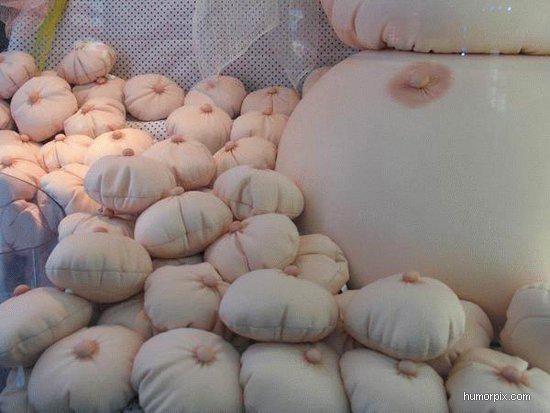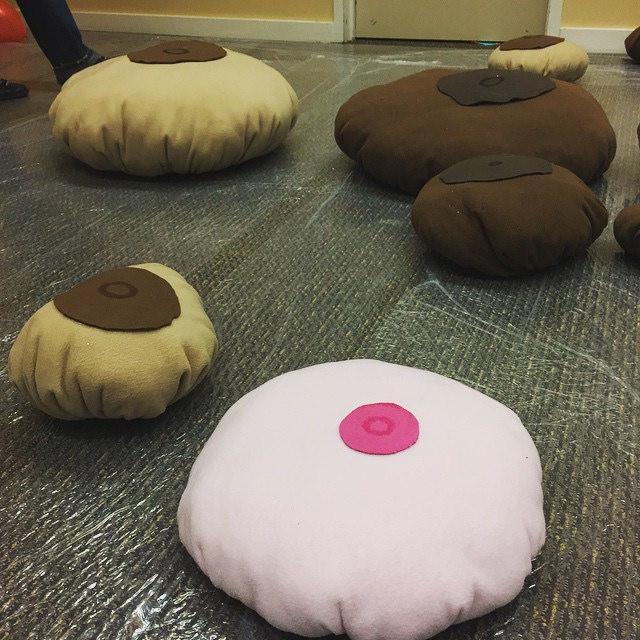The first image is the image on the left, the second image is the image on the right. For the images shown, is this caption "There is a single white pillow with a pair of breasts on them." true? Answer yes or no. No. 